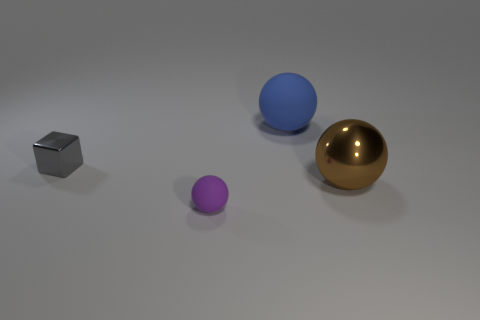Subtract all cyan spheres. Subtract all cyan blocks. How many spheres are left? 3 Add 3 cyan rubber objects. How many objects exist? 7 Subtract all cubes. How many objects are left? 3 Subtract 0 gray cylinders. How many objects are left? 4 Subtract all blue rubber objects. Subtract all small purple spheres. How many objects are left? 2 Add 2 blue objects. How many blue objects are left? 3 Add 3 big gray rubber things. How many big gray rubber things exist? 3 